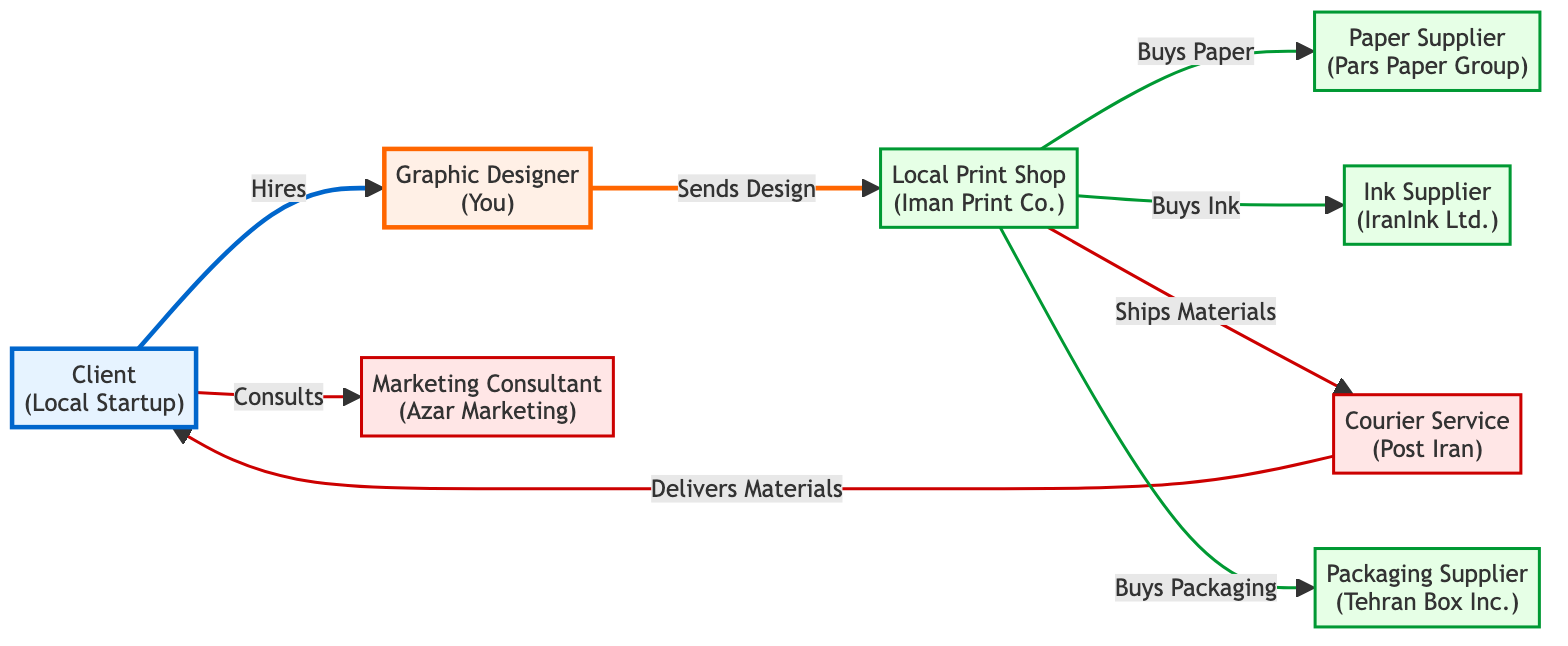What type of business is represented by the "Client" node? The "Client" node specifically represents a "Local Startup" as indicated in the label.
Answer: Local Startup How many suppliers are present in the diagram? The diagram lists four suppliers: Paper Supplier, Ink Supplier, Packaging Supplier, and Local Print Shop. Therefore, adding these together gives a total of four suppliers.
Answer: 4 Who does the "Graphic Designer" send designs to? The "Graphic Designer" node has a directed edge to "Local Print Shop," indicating that designs are sent to the Local Print Shop.
Answer: Local Print Shop What service does the "Courier Service" provide? The "Courier Service" has a directed relationship from "Local Print Shop" indicating they "Ship Materials," and another to "Client" where they "Deliver Materials." This signifies that the courier service operates to deliver materials to the client.
Answer: Delivers Materials If a Local Print Shop purchases both paper and ink, how many items does it buy? The diagram shows that the Local Print Shop has two separate edges pointing to the Paper Supplier and Ink Supplier, indicating that it buys both items. Therefore, summing these purchases results in a total of two items.
Answer: 2 What role does the "Marketing Consultant" play in relation to the "Client"? The directed edge from "Client" to "Marketing Consultant" indicates that the client engages the marketing consultant for consultation, establishing that the consultant provides marketing advice to the client.
Answer: Consults Which node has the most connections? The "Local Print Shop" node connects to three suppliers (Paper Supplier, Ink Supplier, Packaging Supplier) and connects to two other nodes for service delivery (Courier Service and Graphic Designer), leading to a total of five connections.
Answer: Local Print Shop What is the relationship between the "Client" and the "Graphic Designer"? The directed edge from the "Client" to the "Graphic Designer" indicates that the client hires the graphic designer, establishing a client-designer relationship.
Answer: Hires How does the "Courier Service" relate to the "Local Print Shop"? The diagram shows a relationship where the Local Print Shop ships materials through the Courier Service, portraying a functional link between them that facilitates logistics.
Answer: Ships Materials Which node represents packaging supply in the diagram? The "Packaging Supplier" node is directly labeled as such, indicating it serves as the specific source of packaging materials within this network.
Answer: Packaging Supplier 